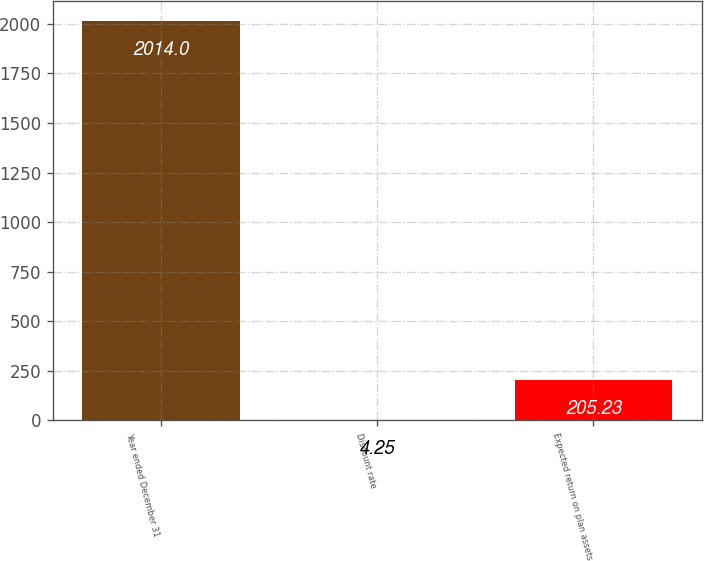<chart> <loc_0><loc_0><loc_500><loc_500><bar_chart><fcel>Year ended December 31<fcel>Discount rate<fcel>Expected return on plan assets<nl><fcel>2014<fcel>4.25<fcel>205.23<nl></chart> 